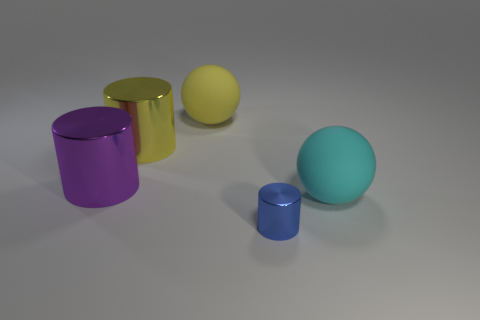Add 1 blue things. How many objects exist? 6 Subtract all cylinders. How many objects are left? 2 Subtract all large green shiny things. Subtract all large cyan rubber things. How many objects are left? 4 Add 1 big purple objects. How many big purple objects are left? 2 Add 4 big cyan rubber things. How many big cyan rubber things exist? 5 Subtract 1 cyan spheres. How many objects are left? 4 